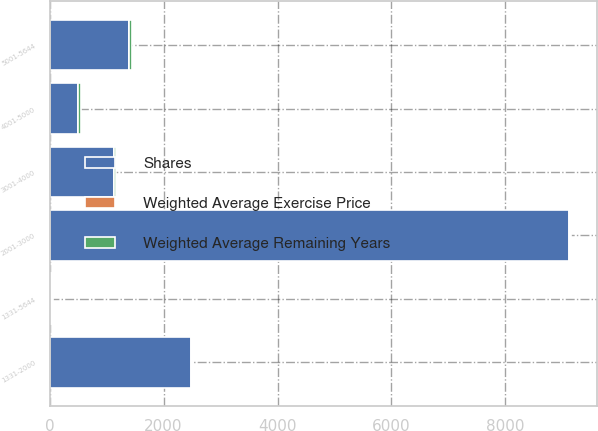Convert chart. <chart><loc_0><loc_0><loc_500><loc_500><stacked_bar_chart><ecel><fcel>1331-2000<fcel>2001-3000<fcel>3001-4000<fcel>4001-5000<fcel>5001-5644<fcel>1331-5644<nl><fcel>Shares<fcel>2489<fcel>9126<fcel>1126<fcel>493<fcel>1384<fcel>29.33<nl><fcel>Weighted Average Remaining Years<fcel>18.66<fcel>26.92<fcel>35.73<fcel>47.22<fcel>52.85<fcel>29.33<nl><fcel>Weighted Average Exercise Price<fcel>4.3<fcel>4.69<fcel>1.26<fcel>0.72<fcel>0.76<fcel>3.85<nl></chart> 